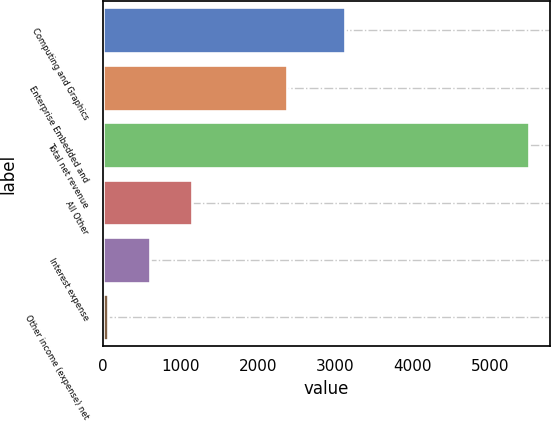Convert chart. <chart><loc_0><loc_0><loc_500><loc_500><bar_chart><fcel>Computing and Graphics<fcel>Enterprise Embedded and<fcel>Total net revenue<fcel>All Other<fcel>Interest expense<fcel>Other income (expense) net<nl><fcel>3132<fcel>2374<fcel>5506<fcel>1154<fcel>610<fcel>66<nl></chart> 